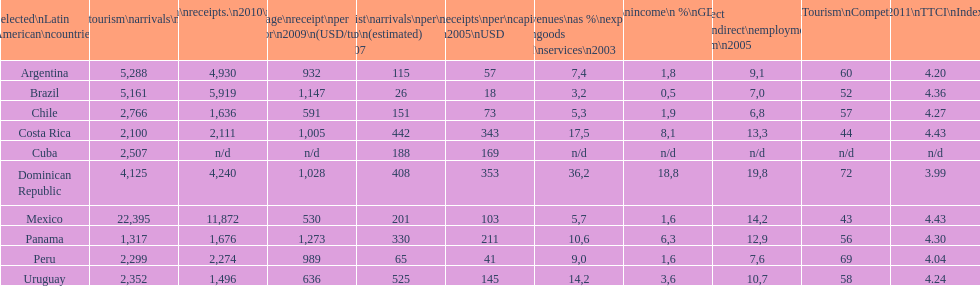What country had the most receipts per capita in 2005? Dominican Republic. 